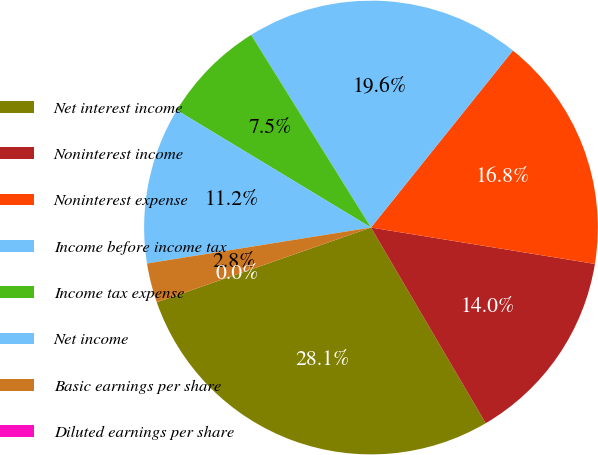<chart> <loc_0><loc_0><loc_500><loc_500><pie_chart><fcel>Net interest income<fcel>Noninterest income<fcel>Noninterest expense<fcel>Income before income tax<fcel>Income tax expense<fcel>Net income<fcel>Basic earnings per share<fcel>Diluted earnings per share<nl><fcel>28.1%<fcel>14.0%<fcel>16.81%<fcel>19.62%<fcel>7.49%<fcel>11.19%<fcel>2.81%<fcel>0.0%<nl></chart> 